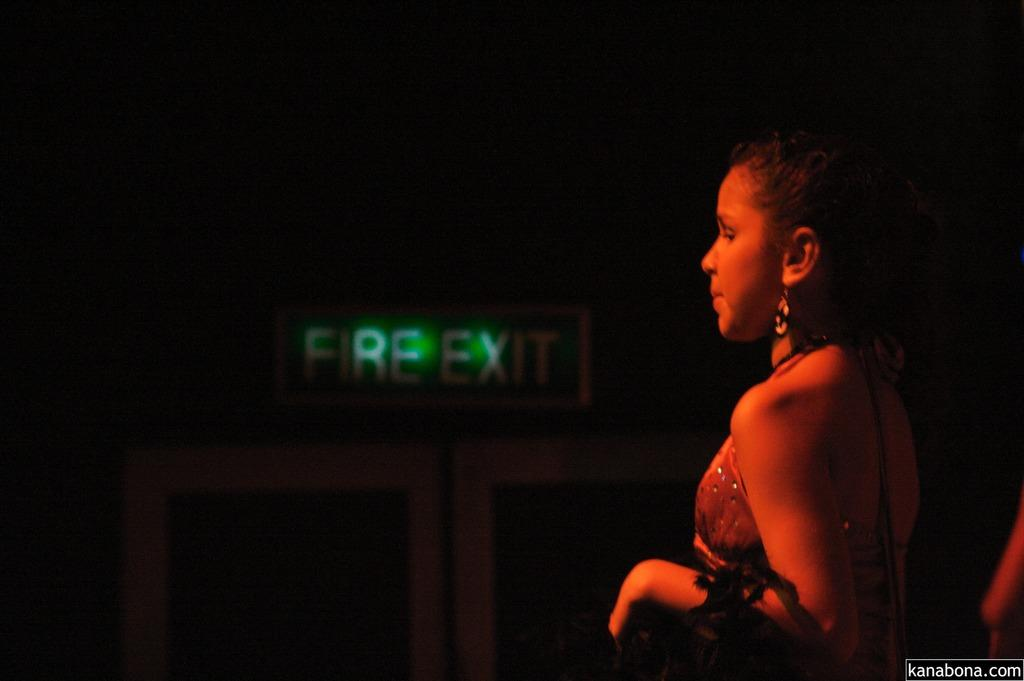Who is present on the right side of the image? There is a woman on the right side of the image. What can be seen in the background of the image? There is a wall and a door in the background of the image. What type of cattle can be seen grazing in the image? There are no cattle present in the image; it features a woman and a wall with a door in the background. 